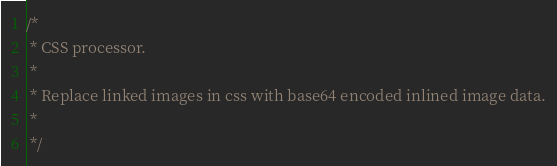<code> <loc_0><loc_0><loc_500><loc_500><_JavaScript_>/*
 * CSS processor.
 *
 * Replace linked images in css with base64 encoded inlined image data.
 *
 */
</code> 